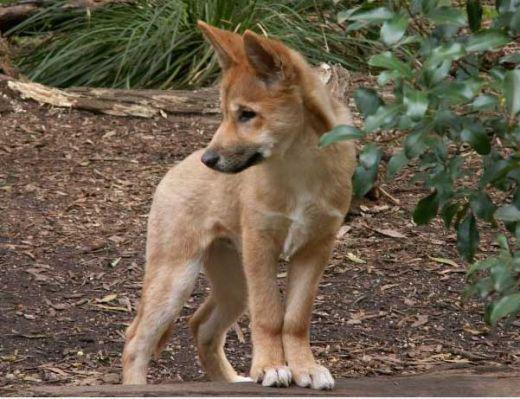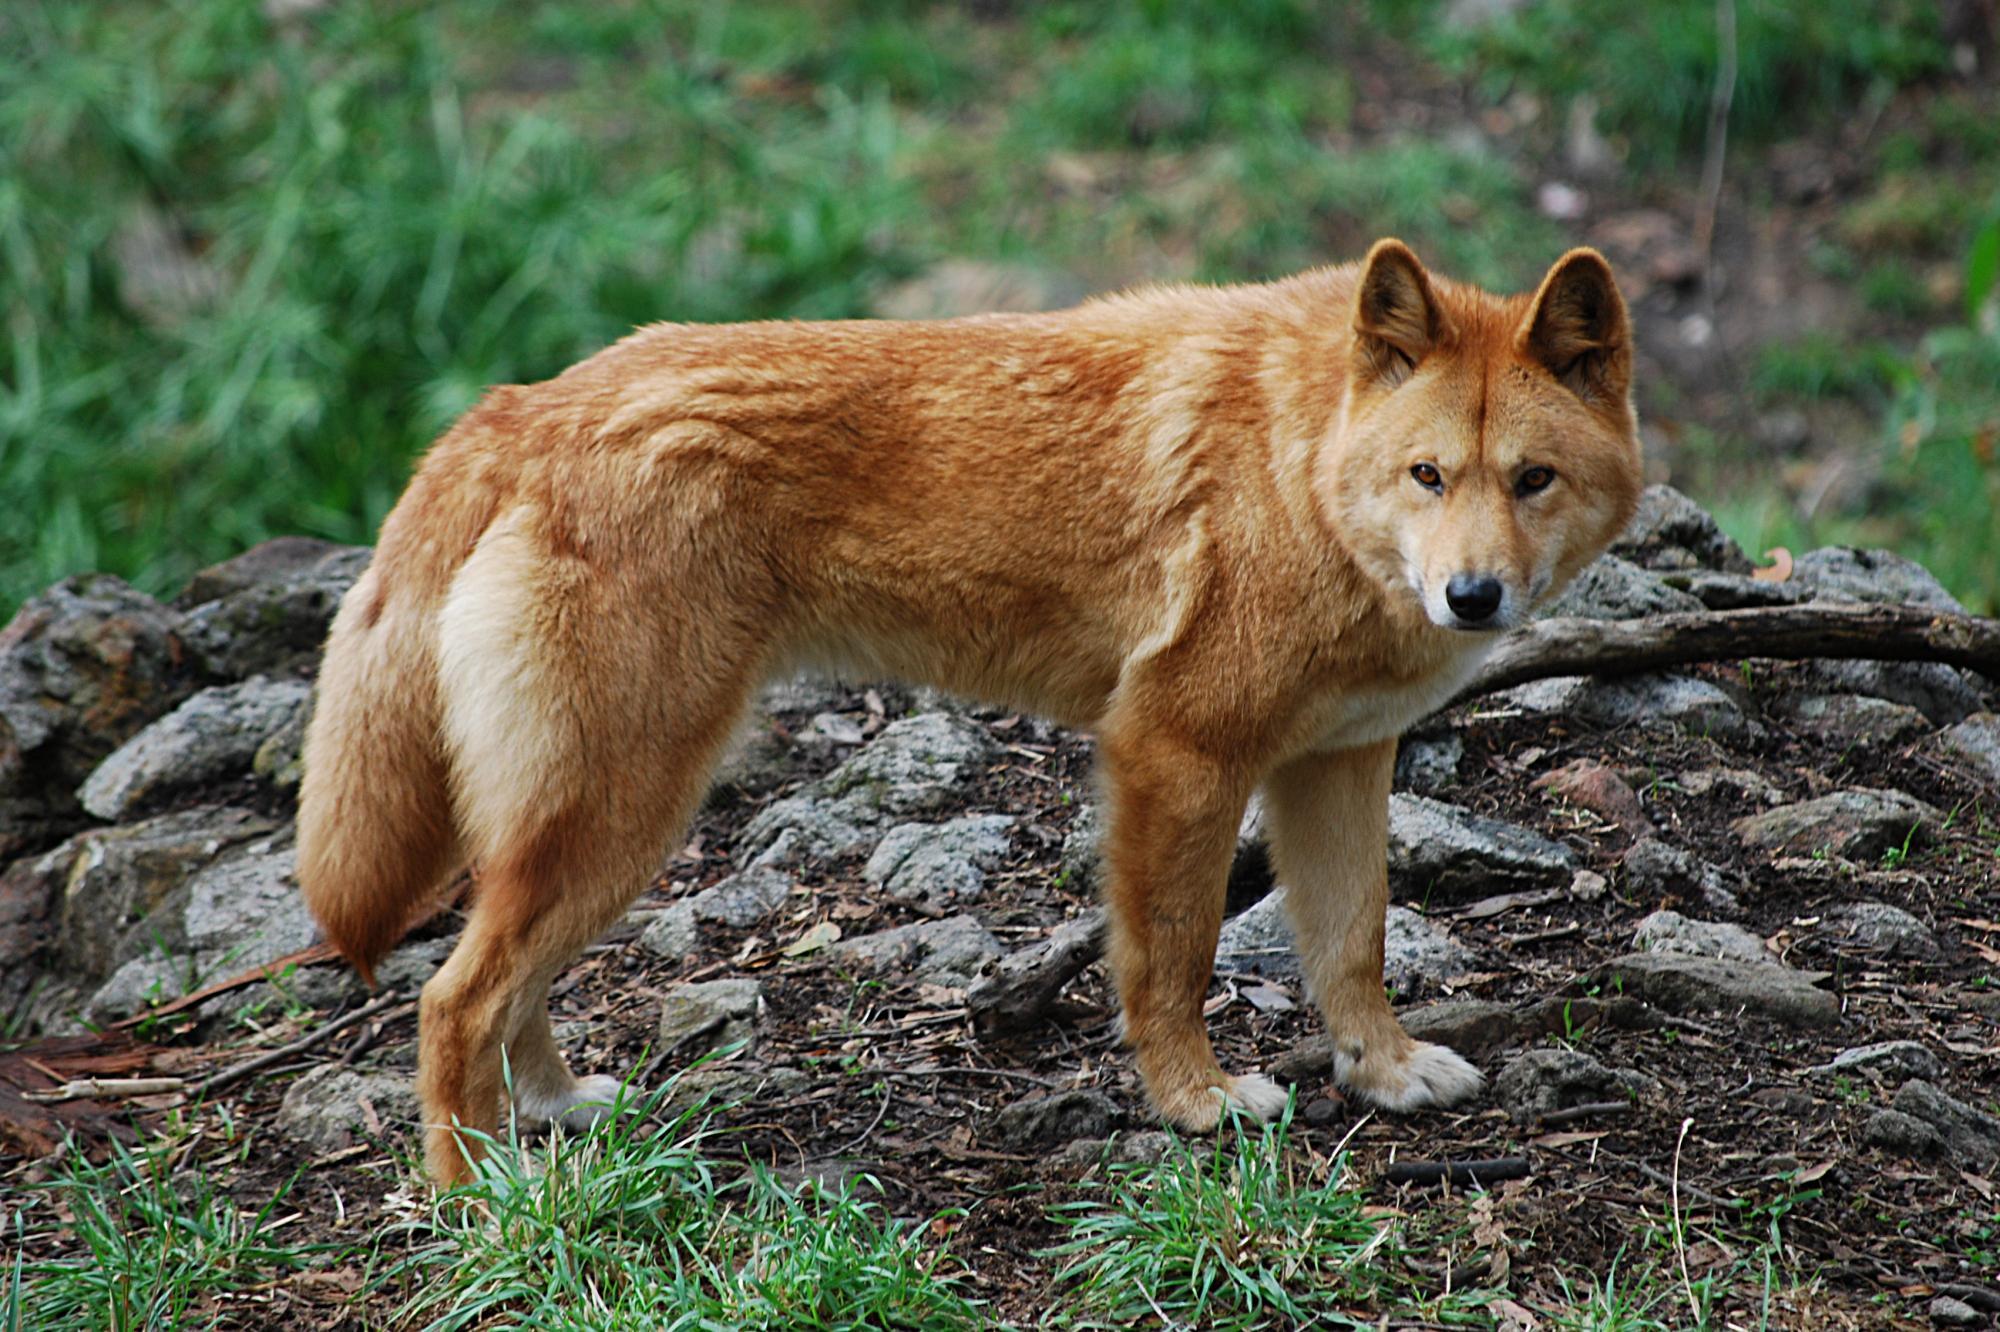The first image is the image on the left, the second image is the image on the right. Given the left and right images, does the statement "At least one animal is lying on the ground in the image on the right." hold true? Answer yes or no. No. 